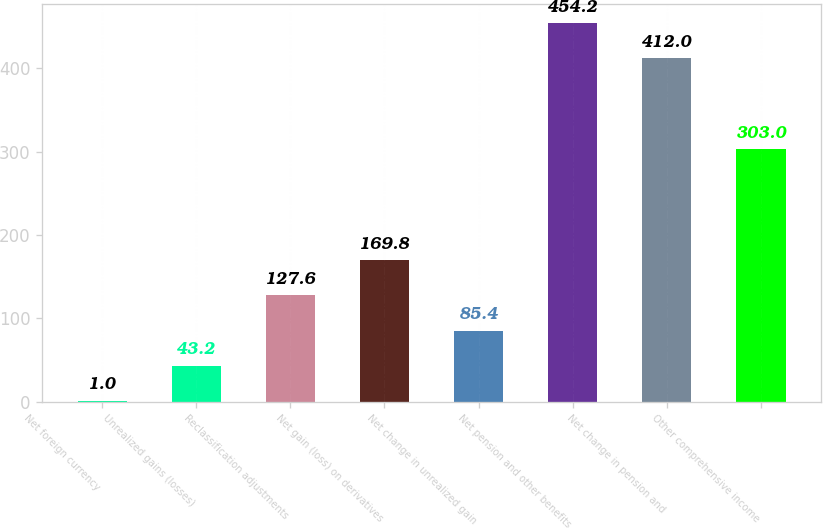Convert chart. <chart><loc_0><loc_0><loc_500><loc_500><bar_chart><fcel>Net foreign currency<fcel>Unrealized gains (losses)<fcel>Reclassification adjustments<fcel>Net gain (loss) on derivatives<fcel>Net change in unrealized gain<fcel>Net pension and other benefits<fcel>Net change in pension and<fcel>Other comprehensive income<nl><fcel>1<fcel>43.2<fcel>127.6<fcel>169.8<fcel>85.4<fcel>454.2<fcel>412<fcel>303<nl></chart> 